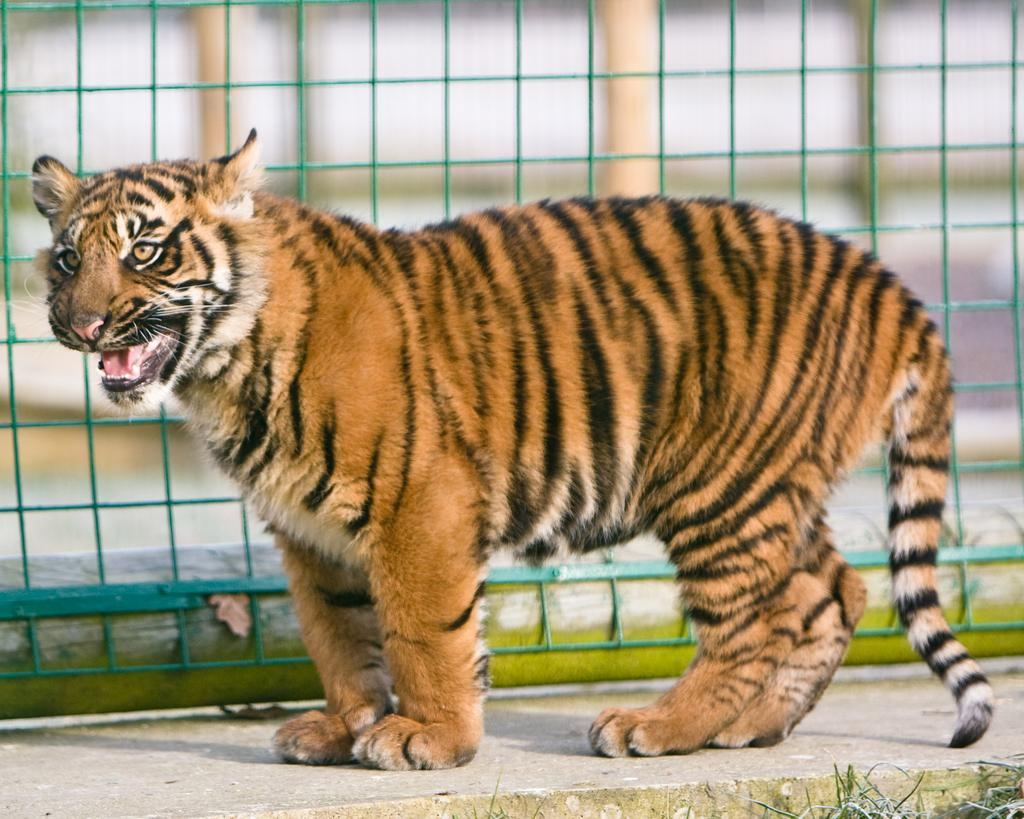What animal is present in the image? There is a tiger in the image. What is the tiger's position in the image? The tiger is standing on the ground. What can be seen in the background of the image? There is an iron fencing in the background of the image. What type of apparel is the tiger wearing in the image? The tiger is not wearing any apparel in the image. Who is the tiger representing in the image? The tiger is not representing anyone in the image; it is simply a tiger. 